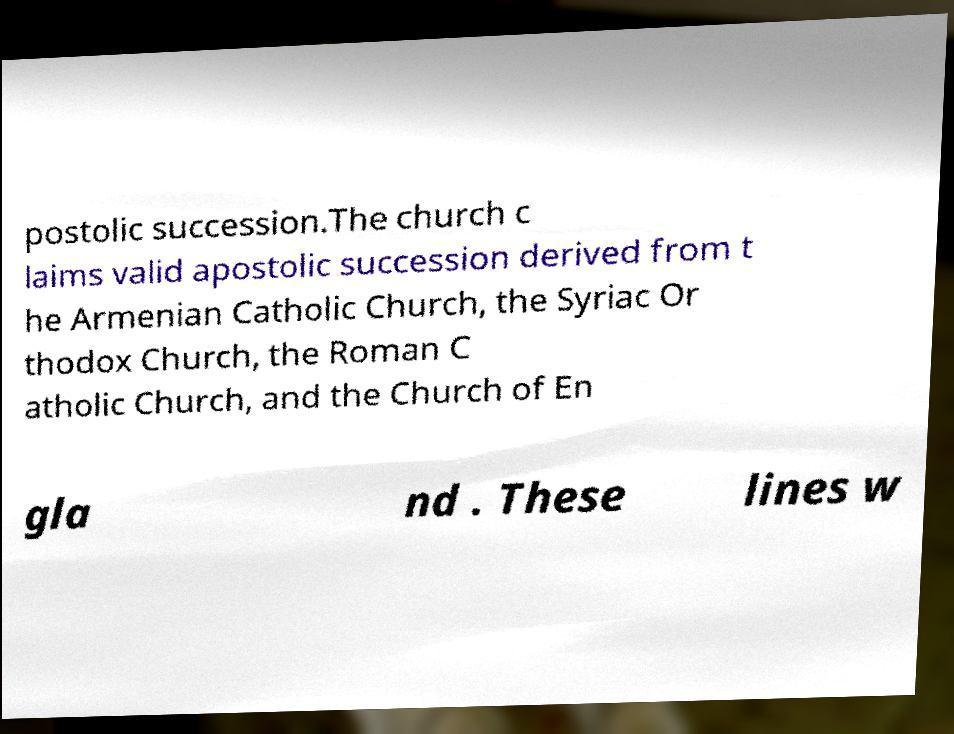I need the written content from this picture converted into text. Can you do that? postolic succession.The church c laims valid apostolic succession derived from t he Armenian Catholic Church, the Syriac Or thodox Church, the Roman C atholic Church, and the Church of En gla nd . These lines w 